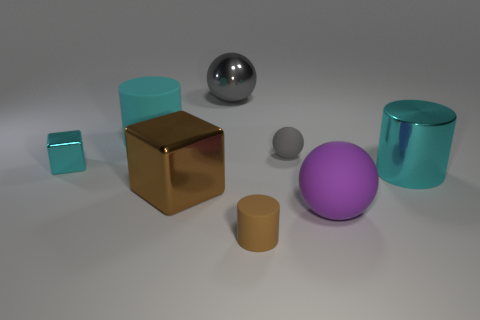What number of things are either cyan cylinders that are on the left side of the tiny brown cylinder or metallic things that are in front of the big cyan matte thing?
Offer a very short reply. 4. Are there fewer small shiny blocks than cyan metallic objects?
Your answer should be very brief. Yes. There is a brown cylinder; does it have the same size as the rubber sphere behind the tiny cyan shiny object?
Provide a short and direct response. Yes. What number of matte objects are either purple balls or gray things?
Offer a terse response. 2. Is the number of purple matte spheres greater than the number of tiny things?
Your answer should be very brief. No. What size is the cube that is the same color as the big metallic cylinder?
Your response must be concise. Small. There is a metal object that is to the left of the metal block in front of the small block; what shape is it?
Your response must be concise. Cube. There is a big rubber object that is to the right of the large cyan cylinder to the left of the gray matte object; is there a large gray object that is behind it?
Offer a terse response. Yes. There is another sphere that is the same size as the purple sphere; what color is it?
Offer a very short reply. Gray. The rubber object that is behind the purple matte object and to the right of the large matte cylinder has what shape?
Your answer should be very brief. Sphere. 